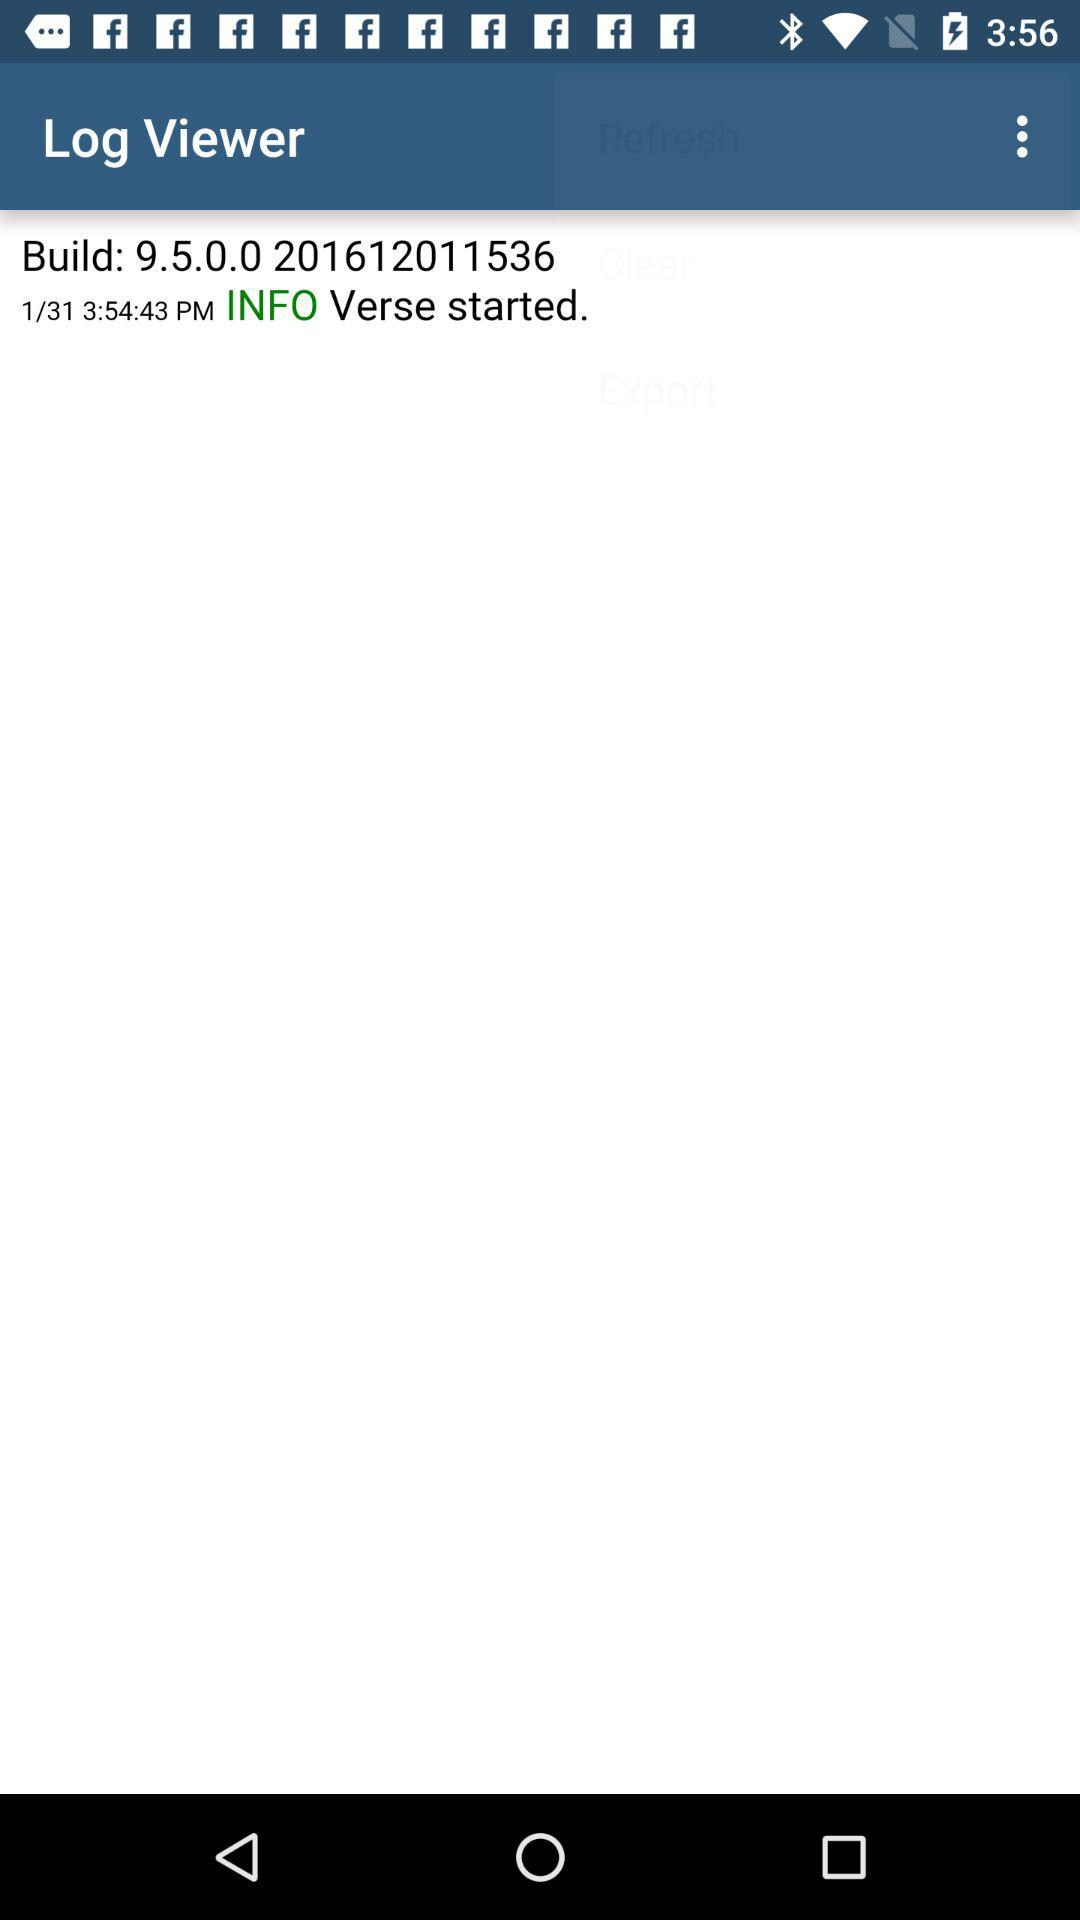What is the time? The time is 3:54:43 p.m. 